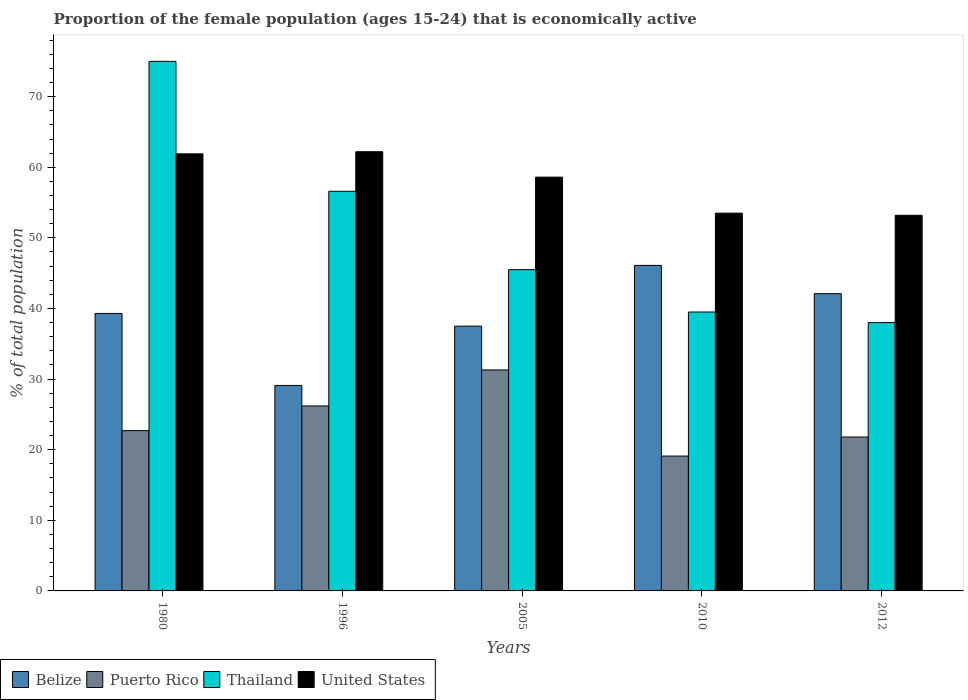How many groups of bars are there?
Your response must be concise. 5. Are the number of bars per tick equal to the number of legend labels?
Your response must be concise. Yes. Are the number of bars on each tick of the X-axis equal?
Give a very brief answer. Yes. How many bars are there on the 1st tick from the left?
Make the answer very short. 4. In how many cases, is the number of bars for a given year not equal to the number of legend labels?
Ensure brevity in your answer.  0. What is the proportion of the female population that is economically active in United States in 1980?
Provide a succinct answer. 61.9. Across all years, what is the minimum proportion of the female population that is economically active in Puerto Rico?
Provide a succinct answer. 19.1. In which year was the proportion of the female population that is economically active in Puerto Rico maximum?
Provide a short and direct response. 2005. In which year was the proportion of the female population that is economically active in Belize minimum?
Offer a very short reply. 1996. What is the total proportion of the female population that is economically active in United States in the graph?
Your answer should be very brief. 289.4. What is the difference between the proportion of the female population that is economically active in Belize in 1980 and that in 1996?
Your answer should be very brief. 10.2. What is the difference between the proportion of the female population that is economically active in Puerto Rico in 2005 and the proportion of the female population that is economically active in United States in 1980?
Provide a succinct answer. -30.6. What is the average proportion of the female population that is economically active in Thailand per year?
Provide a succinct answer. 50.92. In the year 2010, what is the difference between the proportion of the female population that is economically active in United States and proportion of the female population that is economically active in Puerto Rico?
Give a very brief answer. 34.4. In how many years, is the proportion of the female population that is economically active in Belize greater than 48 %?
Your answer should be very brief. 0. What is the ratio of the proportion of the female population that is economically active in Thailand in 2010 to that in 2012?
Your response must be concise. 1.04. Is the proportion of the female population that is economically active in Belize in 1980 less than that in 2005?
Provide a succinct answer. No. What is the difference between the highest and the second highest proportion of the female population that is economically active in United States?
Provide a succinct answer. 0.3. What is the difference between the highest and the lowest proportion of the female population that is economically active in Belize?
Offer a very short reply. 17. Is the sum of the proportion of the female population that is economically active in United States in 1996 and 2010 greater than the maximum proportion of the female population that is economically active in Puerto Rico across all years?
Your answer should be very brief. Yes. Is it the case that in every year, the sum of the proportion of the female population that is economically active in Belize and proportion of the female population that is economically active in Puerto Rico is greater than the sum of proportion of the female population that is economically active in Thailand and proportion of the female population that is economically active in United States?
Make the answer very short. No. What does the 3rd bar from the left in 1980 represents?
Provide a short and direct response. Thailand. Is it the case that in every year, the sum of the proportion of the female population that is economically active in Puerto Rico and proportion of the female population that is economically active in United States is greater than the proportion of the female population that is economically active in Belize?
Your response must be concise. Yes. How many bars are there?
Provide a short and direct response. 20. What is the difference between two consecutive major ticks on the Y-axis?
Give a very brief answer. 10. Are the values on the major ticks of Y-axis written in scientific E-notation?
Ensure brevity in your answer.  No. Does the graph contain any zero values?
Offer a terse response. No. Where does the legend appear in the graph?
Ensure brevity in your answer.  Bottom left. How many legend labels are there?
Ensure brevity in your answer.  4. What is the title of the graph?
Keep it short and to the point. Proportion of the female population (ages 15-24) that is economically active. What is the label or title of the Y-axis?
Provide a short and direct response. % of total population. What is the % of total population of Belize in 1980?
Your response must be concise. 39.3. What is the % of total population in Puerto Rico in 1980?
Keep it short and to the point. 22.7. What is the % of total population of Thailand in 1980?
Your answer should be very brief. 75. What is the % of total population in United States in 1980?
Provide a succinct answer. 61.9. What is the % of total population in Belize in 1996?
Offer a very short reply. 29.1. What is the % of total population of Puerto Rico in 1996?
Make the answer very short. 26.2. What is the % of total population in Thailand in 1996?
Give a very brief answer. 56.6. What is the % of total population of United States in 1996?
Provide a short and direct response. 62.2. What is the % of total population of Belize in 2005?
Offer a terse response. 37.5. What is the % of total population in Puerto Rico in 2005?
Keep it short and to the point. 31.3. What is the % of total population of Thailand in 2005?
Your response must be concise. 45.5. What is the % of total population of United States in 2005?
Provide a succinct answer. 58.6. What is the % of total population of Belize in 2010?
Make the answer very short. 46.1. What is the % of total population of Puerto Rico in 2010?
Your response must be concise. 19.1. What is the % of total population in Thailand in 2010?
Provide a succinct answer. 39.5. What is the % of total population in United States in 2010?
Offer a very short reply. 53.5. What is the % of total population of Belize in 2012?
Provide a succinct answer. 42.1. What is the % of total population in Puerto Rico in 2012?
Your answer should be compact. 21.8. What is the % of total population in United States in 2012?
Your response must be concise. 53.2. Across all years, what is the maximum % of total population of Belize?
Keep it short and to the point. 46.1. Across all years, what is the maximum % of total population in Puerto Rico?
Offer a terse response. 31.3. Across all years, what is the maximum % of total population in Thailand?
Ensure brevity in your answer.  75. Across all years, what is the maximum % of total population in United States?
Offer a very short reply. 62.2. Across all years, what is the minimum % of total population in Belize?
Your answer should be very brief. 29.1. Across all years, what is the minimum % of total population of Puerto Rico?
Provide a succinct answer. 19.1. Across all years, what is the minimum % of total population in Thailand?
Ensure brevity in your answer.  38. Across all years, what is the minimum % of total population of United States?
Give a very brief answer. 53.2. What is the total % of total population in Belize in the graph?
Provide a short and direct response. 194.1. What is the total % of total population in Puerto Rico in the graph?
Your answer should be compact. 121.1. What is the total % of total population in Thailand in the graph?
Ensure brevity in your answer.  254.6. What is the total % of total population of United States in the graph?
Give a very brief answer. 289.4. What is the difference between the % of total population of Belize in 1980 and that in 1996?
Provide a short and direct response. 10.2. What is the difference between the % of total population in Puerto Rico in 1980 and that in 1996?
Keep it short and to the point. -3.5. What is the difference between the % of total population of Belize in 1980 and that in 2005?
Offer a very short reply. 1.8. What is the difference between the % of total population of Thailand in 1980 and that in 2005?
Give a very brief answer. 29.5. What is the difference between the % of total population in United States in 1980 and that in 2005?
Keep it short and to the point. 3.3. What is the difference between the % of total population in Belize in 1980 and that in 2010?
Your answer should be compact. -6.8. What is the difference between the % of total population of Puerto Rico in 1980 and that in 2010?
Your response must be concise. 3.6. What is the difference between the % of total population of Thailand in 1980 and that in 2010?
Provide a succinct answer. 35.5. What is the difference between the % of total population in United States in 1980 and that in 2010?
Your answer should be compact. 8.4. What is the difference between the % of total population in Puerto Rico in 1980 and that in 2012?
Your answer should be very brief. 0.9. What is the difference between the % of total population of United States in 1980 and that in 2012?
Give a very brief answer. 8.7. What is the difference between the % of total population in Belize in 1996 and that in 2005?
Your answer should be very brief. -8.4. What is the difference between the % of total population of United States in 1996 and that in 2005?
Make the answer very short. 3.6. What is the difference between the % of total population of Belize in 1996 and that in 2010?
Give a very brief answer. -17. What is the difference between the % of total population of Thailand in 1996 and that in 2010?
Make the answer very short. 17.1. What is the difference between the % of total population in United States in 1996 and that in 2010?
Keep it short and to the point. 8.7. What is the difference between the % of total population of Belize in 1996 and that in 2012?
Keep it short and to the point. -13. What is the difference between the % of total population of Thailand in 1996 and that in 2012?
Provide a short and direct response. 18.6. What is the difference between the % of total population of United States in 1996 and that in 2012?
Keep it short and to the point. 9. What is the difference between the % of total population of Belize in 2005 and that in 2010?
Your response must be concise. -8.6. What is the difference between the % of total population in Puerto Rico in 2005 and that in 2010?
Your answer should be very brief. 12.2. What is the difference between the % of total population in Thailand in 2005 and that in 2010?
Provide a succinct answer. 6. What is the difference between the % of total population of Thailand in 2005 and that in 2012?
Make the answer very short. 7.5. What is the difference between the % of total population in United States in 2005 and that in 2012?
Offer a very short reply. 5.4. What is the difference between the % of total population of Belize in 2010 and that in 2012?
Ensure brevity in your answer.  4. What is the difference between the % of total population of United States in 2010 and that in 2012?
Give a very brief answer. 0.3. What is the difference between the % of total population of Belize in 1980 and the % of total population of Puerto Rico in 1996?
Provide a succinct answer. 13.1. What is the difference between the % of total population of Belize in 1980 and the % of total population of Thailand in 1996?
Your response must be concise. -17.3. What is the difference between the % of total population in Belize in 1980 and the % of total population in United States in 1996?
Give a very brief answer. -22.9. What is the difference between the % of total population in Puerto Rico in 1980 and the % of total population in Thailand in 1996?
Your answer should be very brief. -33.9. What is the difference between the % of total population in Puerto Rico in 1980 and the % of total population in United States in 1996?
Make the answer very short. -39.5. What is the difference between the % of total population in Belize in 1980 and the % of total population in Thailand in 2005?
Provide a short and direct response. -6.2. What is the difference between the % of total population of Belize in 1980 and the % of total population of United States in 2005?
Your response must be concise. -19.3. What is the difference between the % of total population of Puerto Rico in 1980 and the % of total population of Thailand in 2005?
Provide a short and direct response. -22.8. What is the difference between the % of total population in Puerto Rico in 1980 and the % of total population in United States in 2005?
Make the answer very short. -35.9. What is the difference between the % of total population of Belize in 1980 and the % of total population of Puerto Rico in 2010?
Give a very brief answer. 20.2. What is the difference between the % of total population in Puerto Rico in 1980 and the % of total population in Thailand in 2010?
Offer a terse response. -16.8. What is the difference between the % of total population in Puerto Rico in 1980 and the % of total population in United States in 2010?
Provide a succinct answer. -30.8. What is the difference between the % of total population in Thailand in 1980 and the % of total population in United States in 2010?
Give a very brief answer. 21.5. What is the difference between the % of total population of Belize in 1980 and the % of total population of Thailand in 2012?
Give a very brief answer. 1.3. What is the difference between the % of total population of Puerto Rico in 1980 and the % of total population of Thailand in 2012?
Offer a terse response. -15.3. What is the difference between the % of total population in Puerto Rico in 1980 and the % of total population in United States in 2012?
Offer a terse response. -30.5. What is the difference between the % of total population in Thailand in 1980 and the % of total population in United States in 2012?
Provide a short and direct response. 21.8. What is the difference between the % of total population of Belize in 1996 and the % of total population of Puerto Rico in 2005?
Your answer should be compact. -2.2. What is the difference between the % of total population in Belize in 1996 and the % of total population in Thailand in 2005?
Give a very brief answer. -16.4. What is the difference between the % of total population in Belize in 1996 and the % of total population in United States in 2005?
Your response must be concise. -29.5. What is the difference between the % of total population in Puerto Rico in 1996 and the % of total population in Thailand in 2005?
Provide a succinct answer. -19.3. What is the difference between the % of total population in Puerto Rico in 1996 and the % of total population in United States in 2005?
Your answer should be compact. -32.4. What is the difference between the % of total population in Belize in 1996 and the % of total population in Puerto Rico in 2010?
Offer a terse response. 10. What is the difference between the % of total population of Belize in 1996 and the % of total population of Thailand in 2010?
Provide a short and direct response. -10.4. What is the difference between the % of total population in Belize in 1996 and the % of total population in United States in 2010?
Your answer should be very brief. -24.4. What is the difference between the % of total population of Puerto Rico in 1996 and the % of total population of United States in 2010?
Your answer should be compact. -27.3. What is the difference between the % of total population in Thailand in 1996 and the % of total population in United States in 2010?
Your answer should be compact. 3.1. What is the difference between the % of total population in Belize in 1996 and the % of total population in Puerto Rico in 2012?
Offer a terse response. 7.3. What is the difference between the % of total population of Belize in 1996 and the % of total population of Thailand in 2012?
Offer a very short reply. -8.9. What is the difference between the % of total population in Belize in 1996 and the % of total population in United States in 2012?
Offer a very short reply. -24.1. What is the difference between the % of total population of Puerto Rico in 1996 and the % of total population of United States in 2012?
Offer a very short reply. -27. What is the difference between the % of total population of Thailand in 1996 and the % of total population of United States in 2012?
Your answer should be very brief. 3.4. What is the difference between the % of total population of Puerto Rico in 2005 and the % of total population of United States in 2010?
Your response must be concise. -22.2. What is the difference between the % of total population in Belize in 2005 and the % of total population in Thailand in 2012?
Your response must be concise. -0.5. What is the difference between the % of total population in Belize in 2005 and the % of total population in United States in 2012?
Offer a very short reply. -15.7. What is the difference between the % of total population in Puerto Rico in 2005 and the % of total population in Thailand in 2012?
Provide a short and direct response. -6.7. What is the difference between the % of total population of Puerto Rico in 2005 and the % of total population of United States in 2012?
Provide a short and direct response. -21.9. What is the difference between the % of total population in Thailand in 2005 and the % of total population in United States in 2012?
Your response must be concise. -7.7. What is the difference between the % of total population of Belize in 2010 and the % of total population of Puerto Rico in 2012?
Keep it short and to the point. 24.3. What is the difference between the % of total population of Belize in 2010 and the % of total population of United States in 2012?
Your response must be concise. -7.1. What is the difference between the % of total population in Puerto Rico in 2010 and the % of total population in Thailand in 2012?
Keep it short and to the point. -18.9. What is the difference between the % of total population in Puerto Rico in 2010 and the % of total population in United States in 2012?
Make the answer very short. -34.1. What is the difference between the % of total population in Thailand in 2010 and the % of total population in United States in 2012?
Make the answer very short. -13.7. What is the average % of total population of Belize per year?
Provide a short and direct response. 38.82. What is the average % of total population in Puerto Rico per year?
Your answer should be compact. 24.22. What is the average % of total population in Thailand per year?
Provide a succinct answer. 50.92. What is the average % of total population in United States per year?
Your response must be concise. 57.88. In the year 1980, what is the difference between the % of total population of Belize and % of total population of Puerto Rico?
Ensure brevity in your answer.  16.6. In the year 1980, what is the difference between the % of total population of Belize and % of total population of Thailand?
Provide a succinct answer. -35.7. In the year 1980, what is the difference between the % of total population of Belize and % of total population of United States?
Your answer should be very brief. -22.6. In the year 1980, what is the difference between the % of total population of Puerto Rico and % of total population of Thailand?
Your answer should be compact. -52.3. In the year 1980, what is the difference between the % of total population of Puerto Rico and % of total population of United States?
Ensure brevity in your answer.  -39.2. In the year 1980, what is the difference between the % of total population in Thailand and % of total population in United States?
Ensure brevity in your answer.  13.1. In the year 1996, what is the difference between the % of total population of Belize and % of total population of Puerto Rico?
Make the answer very short. 2.9. In the year 1996, what is the difference between the % of total population in Belize and % of total population in Thailand?
Offer a very short reply. -27.5. In the year 1996, what is the difference between the % of total population in Belize and % of total population in United States?
Make the answer very short. -33.1. In the year 1996, what is the difference between the % of total population in Puerto Rico and % of total population in Thailand?
Ensure brevity in your answer.  -30.4. In the year 1996, what is the difference between the % of total population in Puerto Rico and % of total population in United States?
Your response must be concise. -36. In the year 2005, what is the difference between the % of total population in Belize and % of total population in United States?
Provide a succinct answer. -21.1. In the year 2005, what is the difference between the % of total population of Puerto Rico and % of total population of Thailand?
Give a very brief answer. -14.2. In the year 2005, what is the difference between the % of total population in Puerto Rico and % of total population in United States?
Offer a terse response. -27.3. In the year 2005, what is the difference between the % of total population in Thailand and % of total population in United States?
Ensure brevity in your answer.  -13.1. In the year 2010, what is the difference between the % of total population in Belize and % of total population in Puerto Rico?
Make the answer very short. 27. In the year 2010, what is the difference between the % of total population of Puerto Rico and % of total population of Thailand?
Provide a short and direct response. -20.4. In the year 2010, what is the difference between the % of total population in Puerto Rico and % of total population in United States?
Offer a very short reply. -34.4. In the year 2010, what is the difference between the % of total population in Thailand and % of total population in United States?
Keep it short and to the point. -14. In the year 2012, what is the difference between the % of total population in Belize and % of total population in Puerto Rico?
Offer a very short reply. 20.3. In the year 2012, what is the difference between the % of total population of Belize and % of total population of Thailand?
Provide a short and direct response. 4.1. In the year 2012, what is the difference between the % of total population of Belize and % of total population of United States?
Your response must be concise. -11.1. In the year 2012, what is the difference between the % of total population of Puerto Rico and % of total population of Thailand?
Offer a very short reply. -16.2. In the year 2012, what is the difference between the % of total population of Puerto Rico and % of total population of United States?
Ensure brevity in your answer.  -31.4. In the year 2012, what is the difference between the % of total population of Thailand and % of total population of United States?
Your answer should be very brief. -15.2. What is the ratio of the % of total population of Belize in 1980 to that in 1996?
Provide a short and direct response. 1.35. What is the ratio of the % of total population of Puerto Rico in 1980 to that in 1996?
Your answer should be compact. 0.87. What is the ratio of the % of total population of Thailand in 1980 to that in 1996?
Make the answer very short. 1.33. What is the ratio of the % of total population of United States in 1980 to that in 1996?
Offer a terse response. 1. What is the ratio of the % of total population of Belize in 1980 to that in 2005?
Your response must be concise. 1.05. What is the ratio of the % of total population of Puerto Rico in 1980 to that in 2005?
Your response must be concise. 0.73. What is the ratio of the % of total population in Thailand in 1980 to that in 2005?
Offer a terse response. 1.65. What is the ratio of the % of total population in United States in 1980 to that in 2005?
Provide a short and direct response. 1.06. What is the ratio of the % of total population in Belize in 1980 to that in 2010?
Provide a short and direct response. 0.85. What is the ratio of the % of total population in Puerto Rico in 1980 to that in 2010?
Keep it short and to the point. 1.19. What is the ratio of the % of total population of Thailand in 1980 to that in 2010?
Keep it short and to the point. 1.9. What is the ratio of the % of total population of United States in 1980 to that in 2010?
Your answer should be very brief. 1.16. What is the ratio of the % of total population of Belize in 1980 to that in 2012?
Your answer should be very brief. 0.93. What is the ratio of the % of total population of Puerto Rico in 1980 to that in 2012?
Keep it short and to the point. 1.04. What is the ratio of the % of total population in Thailand in 1980 to that in 2012?
Keep it short and to the point. 1.97. What is the ratio of the % of total population in United States in 1980 to that in 2012?
Ensure brevity in your answer.  1.16. What is the ratio of the % of total population of Belize in 1996 to that in 2005?
Your response must be concise. 0.78. What is the ratio of the % of total population in Puerto Rico in 1996 to that in 2005?
Ensure brevity in your answer.  0.84. What is the ratio of the % of total population in Thailand in 1996 to that in 2005?
Offer a very short reply. 1.24. What is the ratio of the % of total population in United States in 1996 to that in 2005?
Ensure brevity in your answer.  1.06. What is the ratio of the % of total population of Belize in 1996 to that in 2010?
Your answer should be compact. 0.63. What is the ratio of the % of total population in Puerto Rico in 1996 to that in 2010?
Give a very brief answer. 1.37. What is the ratio of the % of total population in Thailand in 1996 to that in 2010?
Provide a short and direct response. 1.43. What is the ratio of the % of total population in United States in 1996 to that in 2010?
Keep it short and to the point. 1.16. What is the ratio of the % of total population of Belize in 1996 to that in 2012?
Offer a terse response. 0.69. What is the ratio of the % of total population of Puerto Rico in 1996 to that in 2012?
Offer a very short reply. 1.2. What is the ratio of the % of total population in Thailand in 1996 to that in 2012?
Your response must be concise. 1.49. What is the ratio of the % of total population in United States in 1996 to that in 2012?
Provide a short and direct response. 1.17. What is the ratio of the % of total population in Belize in 2005 to that in 2010?
Provide a short and direct response. 0.81. What is the ratio of the % of total population of Puerto Rico in 2005 to that in 2010?
Make the answer very short. 1.64. What is the ratio of the % of total population of Thailand in 2005 to that in 2010?
Provide a succinct answer. 1.15. What is the ratio of the % of total population of United States in 2005 to that in 2010?
Provide a succinct answer. 1.1. What is the ratio of the % of total population in Belize in 2005 to that in 2012?
Keep it short and to the point. 0.89. What is the ratio of the % of total population in Puerto Rico in 2005 to that in 2012?
Your response must be concise. 1.44. What is the ratio of the % of total population in Thailand in 2005 to that in 2012?
Give a very brief answer. 1.2. What is the ratio of the % of total population in United States in 2005 to that in 2012?
Give a very brief answer. 1.1. What is the ratio of the % of total population of Belize in 2010 to that in 2012?
Make the answer very short. 1.09. What is the ratio of the % of total population of Puerto Rico in 2010 to that in 2012?
Keep it short and to the point. 0.88. What is the ratio of the % of total population in Thailand in 2010 to that in 2012?
Provide a short and direct response. 1.04. What is the ratio of the % of total population in United States in 2010 to that in 2012?
Provide a short and direct response. 1.01. What is the difference between the highest and the second highest % of total population of Puerto Rico?
Ensure brevity in your answer.  5.1. What is the difference between the highest and the second highest % of total population in United States?
Offer a very short reply. 0.3. What is the difference between the highest and the lowest % of total population of Puerto Rico?
Give a very brief answer. 12.2. What is the difference between the highest and the lowest % of total population in United States?
Give a very brief answer. 9. 